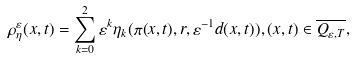Convert formula to latex. <formula><loc_0><loc_0><loc_500><loc_500>\rho _ { \eta } ^ { \varepsilon } ( x , t ) = \sum _ { k = 0 } ^ { 2 } \varepsilon ^ { k } \eta _ { k } ( \pi ( x , t ) , r , \varepsilon ^ { - 1 } d ( x , t ) ) , ( x , t ) \in \overline { Q _ { \varepsilon , T } } ,</formula> 